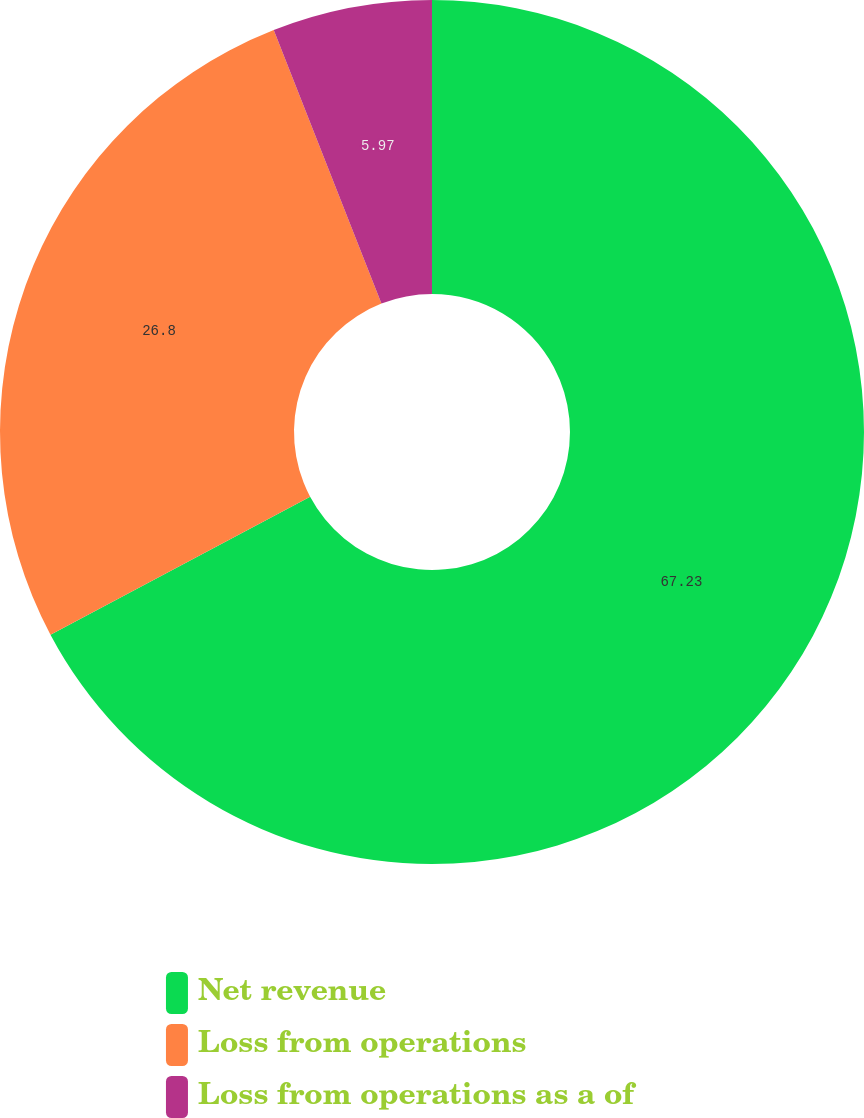<chart> <loc_0><loc_0><loc_500><loc_500><pie_chart><fcel>Net revenue<fcel>Loss from operations<fcel>Loss from operations as a of<nl><fcel>67.23%<fcel>26.8%<fcel>5.97%<nl></chart> 